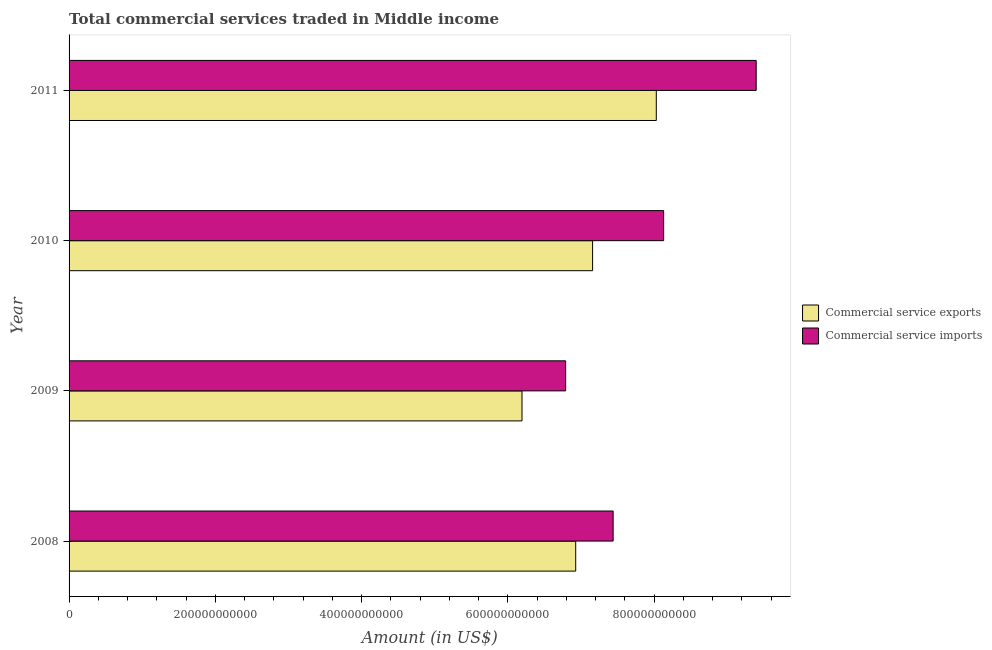How many different coloured bars are there?
Keep it short and to the point. 2. How many groups of bars are there?
Make the answer very short. 4. Are the number of bars on each tick of the Y-axis equal?
Provide a succinct answer. Yes. What is the label of the 2nd group of bars from the top?
Your answer should be compact. 2010. In how many cases, is the number of bars for a given year not equal to the number of legend labels?
Ensure brevity in your answer.  0. What is the amount of commercial service exports in 2010?
Your answer should be very brief. 7.16e+11. Across all years, what is the maximum amount of commercial service imports?
Give a very brief answer. 9.40e+11. Across all years, what is the minimum amount of commercial service imports?
Provide a succinct answer. 6.79e+11. In which year was the amount of commercial service imports maximum?
Give a very brief answer. 2011. What is the total amount of commercial service exports in the graph?
Your answer should be compact. 2.83e+12. What is the difference between the amount of commercial service imports in 2008 and that in 2009?
Offer a terse response. 6.49e+1. What is the difference between the amount of commercial service exports in 2008 and the amount of commercial service imports in 2009?
Offer a very short reply. 1.38e+1. What is the average amount of commercial service imports per year?
Your answer should be very brief. 7.94e+11. In the year 2009, what is the difference between the amount of commercial service imports and amount of commercial service exports?
Keep it short and to the point. 5.97e+1. What is the ratio of the amount of commercial service exports in 2008 to that in 2011?
Offer a very short reply. 0.86. Is the difference between the amount of commercial service exports in 2009 and 2011 greater than the difference between the amount of commercial service imports in 2009 and 2011?
Make the answer very short. Yes. What is the difference between the highest and the second highest amount of commercial service imports?
Keep it short and to the point. 1.27e+11. What is the difference between the highest and the lowest amount of commercial service exports?
Provide a short and direct response. 1.84e+11. What does the 2nd bar from the top in 2010 represents?
Offer a very short reply. Commercial service exports. What does the 1st bar from the bottom in 2008 represents?
Offer a terse response. Commercial service exports. How many bars are there?
Keep it short and to the point. 8. Are all the bars in the graph horizontal?
Provide a succinct answer. Yes. What is the difference between two consecutive major ticks on the X-axis?
Your response must be concise. 2.00e+11. Does the graph contain grids?
Offer a very short reply. No. Where does the legend appear in the graph?
Ensure brevity in your answer.  Center right. How many legend labels are there?
Offer a very short reply. 2. How are the legend labels stacked?
Make the answer very short. Vertical. What is the title of the graph?
Your answer should be compact. Total commercial services traded in Middle income. Does "Excluding technical cooperation" appear as one of the legend labels in the graph?
Make the answer very short. No. What is the label or title of the X-axis?
Ensure brevity in your answer.  Amount (in US$). What is the label or title of the Y-axis?
Give a very brief answer. Year. What is the Amount (in US$) in Commercial service exports in 2008?
Make the answer very short. 6.93e+11. What is the Amount (in US$) of Commercial service imports in 2008?
Your response must be concise. 7.44e+11. What is the Amount (in US$) of Commercial service exports in 2009?
Provide a short and direct response. 6.19e+11. What is the Amount (in US$) in Commercial service imports in 2009?
Keep it short and to the point. 6.79e+11. What is the Amount (in US$) of Commercial service exports in 2010?
Your answer should be very brief. 7.16e+11. What is the Amount (in US$) of Commercial service imports in 2010?
Offer a very short reply. 8.13e+11. What is the Amount (in US$) of Commercial service exports in 2011?
Give a very brief answer. 8.03e+11. What is the Amount (in US$) of Commercial service imports in 2011?
Provide a short and direct response. 9.40e+11. Across all years, what is the maximum Amount (in US$) of Commercial service exports?
Keep it short and to the point. 8.03e+11. Across all years, what is the maximum Amount (in US$) in Commercial service imports?
Offer a very short reply. 9.40e+11. Across all years, what is the minimum Amount (in US$) of Commercial service exports?
Ensure brevity in your answer.  6.19e+11. Across all years, what is the minimum Amount (in US$) of Commercial service imports?
Offer a very short reply. 6.79e+11. What is the total Amount (in US$) in Commercial service exports in the graph?
Provide a short and direct response. 2.83e+12. What is the total Amount (in US$) in Commercial service imports in the graph?
Offer a terse response. 3.18e+12. What is the difference between the Amount (in US$) in Commercial service exports in 2008 and that in 2009?
Your response must be concise. 7.35e+1. What is the difference between the Amount (in US$) in Commercial service imports in 2008 and that in 2009?
Your response must be concise. 6.49e+1. What is the difference between the Amount (in US$) of Commercial service exports in 2008 and that in 2010?
Ensure brevity in your answer.  -2.31e+1. What is the difference between the Amount (in US$) in Commercial service imports in 2008 and that in 2010?
Make the answer very short. -6.91e+1. What is the difference between the Amount (in US$) of Commercial service exports in 2008 and that in 2011?
Make the answer very short. -1.10e+11. What is the difference between the Amount (in US$) of Commercial service imports in 2008 and that in 2011?
Your answer should be compact. -1.96e+11. What is the difference between the Amount (in US$) in Commercial service exports in 2009 and that in 2010?
Provide a short and direct response. -9.65e+1. What is the difference between the Amount (in US$) in Commercial service imports in 2009 and that in 2010?
Provide a short and direct response. -1.34e+11. What is the difference between the Amount (in US$) of Commercial service exports in 2009 and that in 2011?
Your answer should be compact. -1.84e+11. What is the difference between the Amount (in US$) of Commercial service imports in 2009 and that in 2011?
Provide a short and direct response. -2.61e+11. What is the difference between the Amount (in US$) in Commercial service exports in 2010 and that in 2011?
Ensure brevity in your answer.  -8.71e+1. What is the difference between the Amount (in US$) in Commercial service imports in 2010 and that in 2011?
Your response must be concise. -1.27e+11. What is the difference between the Amount (in US$) in Commercial service exports in 2008 and the Amount (in US$) in Commercial service imports in 2009?
Give a very brief answer. 1.38e+1. What is the difference between the Amount (in US$) in Commercial service exports in 2008 and the Amount (in US$) in Commercial service imports in 2010?
Offer a very short reply. -1.20e+11. What is the difference between the Amount (in US$) of Commercial service exports in 2008 and the Amount (in US$) of Commercial service imports in 2011?
Offer a terse response. -2.47e+11. What is the difference between the Amount (in US$) of Commercial service exports in 2009 and the Amount (in US$) of Commercial service imports in 2010?
Offer a very short reply. -1.94e+11. What is the difference between the Amount (in US$) in Commercial service exports in 2009 and the Amount (in US$) in Commercial service imports in 2011?
Ensure brevity in your answer.  -3.20e+11. What is the difference between the Amount (in US$) in Commercial service exports in 2010 and the Amount (in US$) in Commercial service imports in 2011?
Keep it short and to the point. -2.24e+11. What is the average Amount (in US$) in Commercial service exports per year?
Your answer should be very brief. 7.08e+11. What is the average Amount (in US$) of Commercial service imports per year?
Keep it short and to the point. 7.94e+11. In the year 2008, what is the difference between the Amount (in US$) in Commercial service exports and Amount (in US$) in Commercial service imports?
Keep it short and to the point. -5.12e+1. In the year 2009, what is the difference between the Amount (in US$) of Commercial service exports and Amount (in US$) of Commercial service imports?
Provide a succinct answer. -5.97e+1. In the year 2010, what is the difference between the Amount (in US$) in Commercial service exports and Amount (in US$) in Commercial service imports?
Keep it short and to the point. -9.72e+1. In the year 2011, what is the difference between the Amount (in US$) of Commercial service exports and Amount (in US$) of Commercial service imports?
Your response must be concise. -1.37e+11. What is the ratio of the Amount (in US$) in Commercial service exports in 2008 to that in 2009?
Offer a terse response. 1.12. What is the ratio of the Amount (in US$) in Commercial service imports in 2008 to that in 2009?
Your answer should be compact. 1.1. What is the ratio of the Amount (in US$) in Commercial service exports in 2008 to that in 2010?
Provide a succinct answer. 0.97. What is the ratio of the Amount (in US$) in Commercial service imports in 2008 to that in 2010?
Keep it short and to the point. 0.92. What is the ratio of the Amount (in US$) of Commercial service exports in 2008 to that in 2011?
Your answer should be very brief. 0.86. What is the ratio of the Amount (in US$) of Commercial service imports in 2008 to that in 2011?
Give a very brief answer. 0.79. What is the ratio of the Amount (in US$) in Commercial service exports in 2009 to that in 2010?
Keep it short and to the point. 0.87. What is the ratio of the Amount (in US$) of Commercial service imports in 2009 to that in 2010?
Offer a terse response. 0.84. What is the ratio of the Amount (in US$) of Commercial service exports in 2009 to that in 2011?
Your answer should be very brief. 0.77. What is the ratio of the Amount (in US$) in Commercial service imports in 2009 to that in 2011?
Make the answer very short. 0.72. What is the ratio of the Amount (in US$) of Commercial service exports in 2010 to that in 2011?
Your answer should be very brief. 0.89. What is the ratio of the Amount (in US$) in Commercial service imports in 2010 to that in 2011?
Provide a short and direct response. 0.87. What is the difference between the highest and the second highest Amount (in US$) in Commercial service exports?
Offer a terse response. 8.71e+1. What is the difference between the highest and the second highest Amount (in US$) of Commercial service imports?
Provide a short and direct response. 1.27e+11. What is the difference between the highest and the lowest Amount (in US$) in Commercial service exports?
Provide a short and direct response. 1.84e+11. What is the difference between the highest and the lowest Amount (in US$) of Commercial service imports?
Offer a terse response. 2.61e+11. 